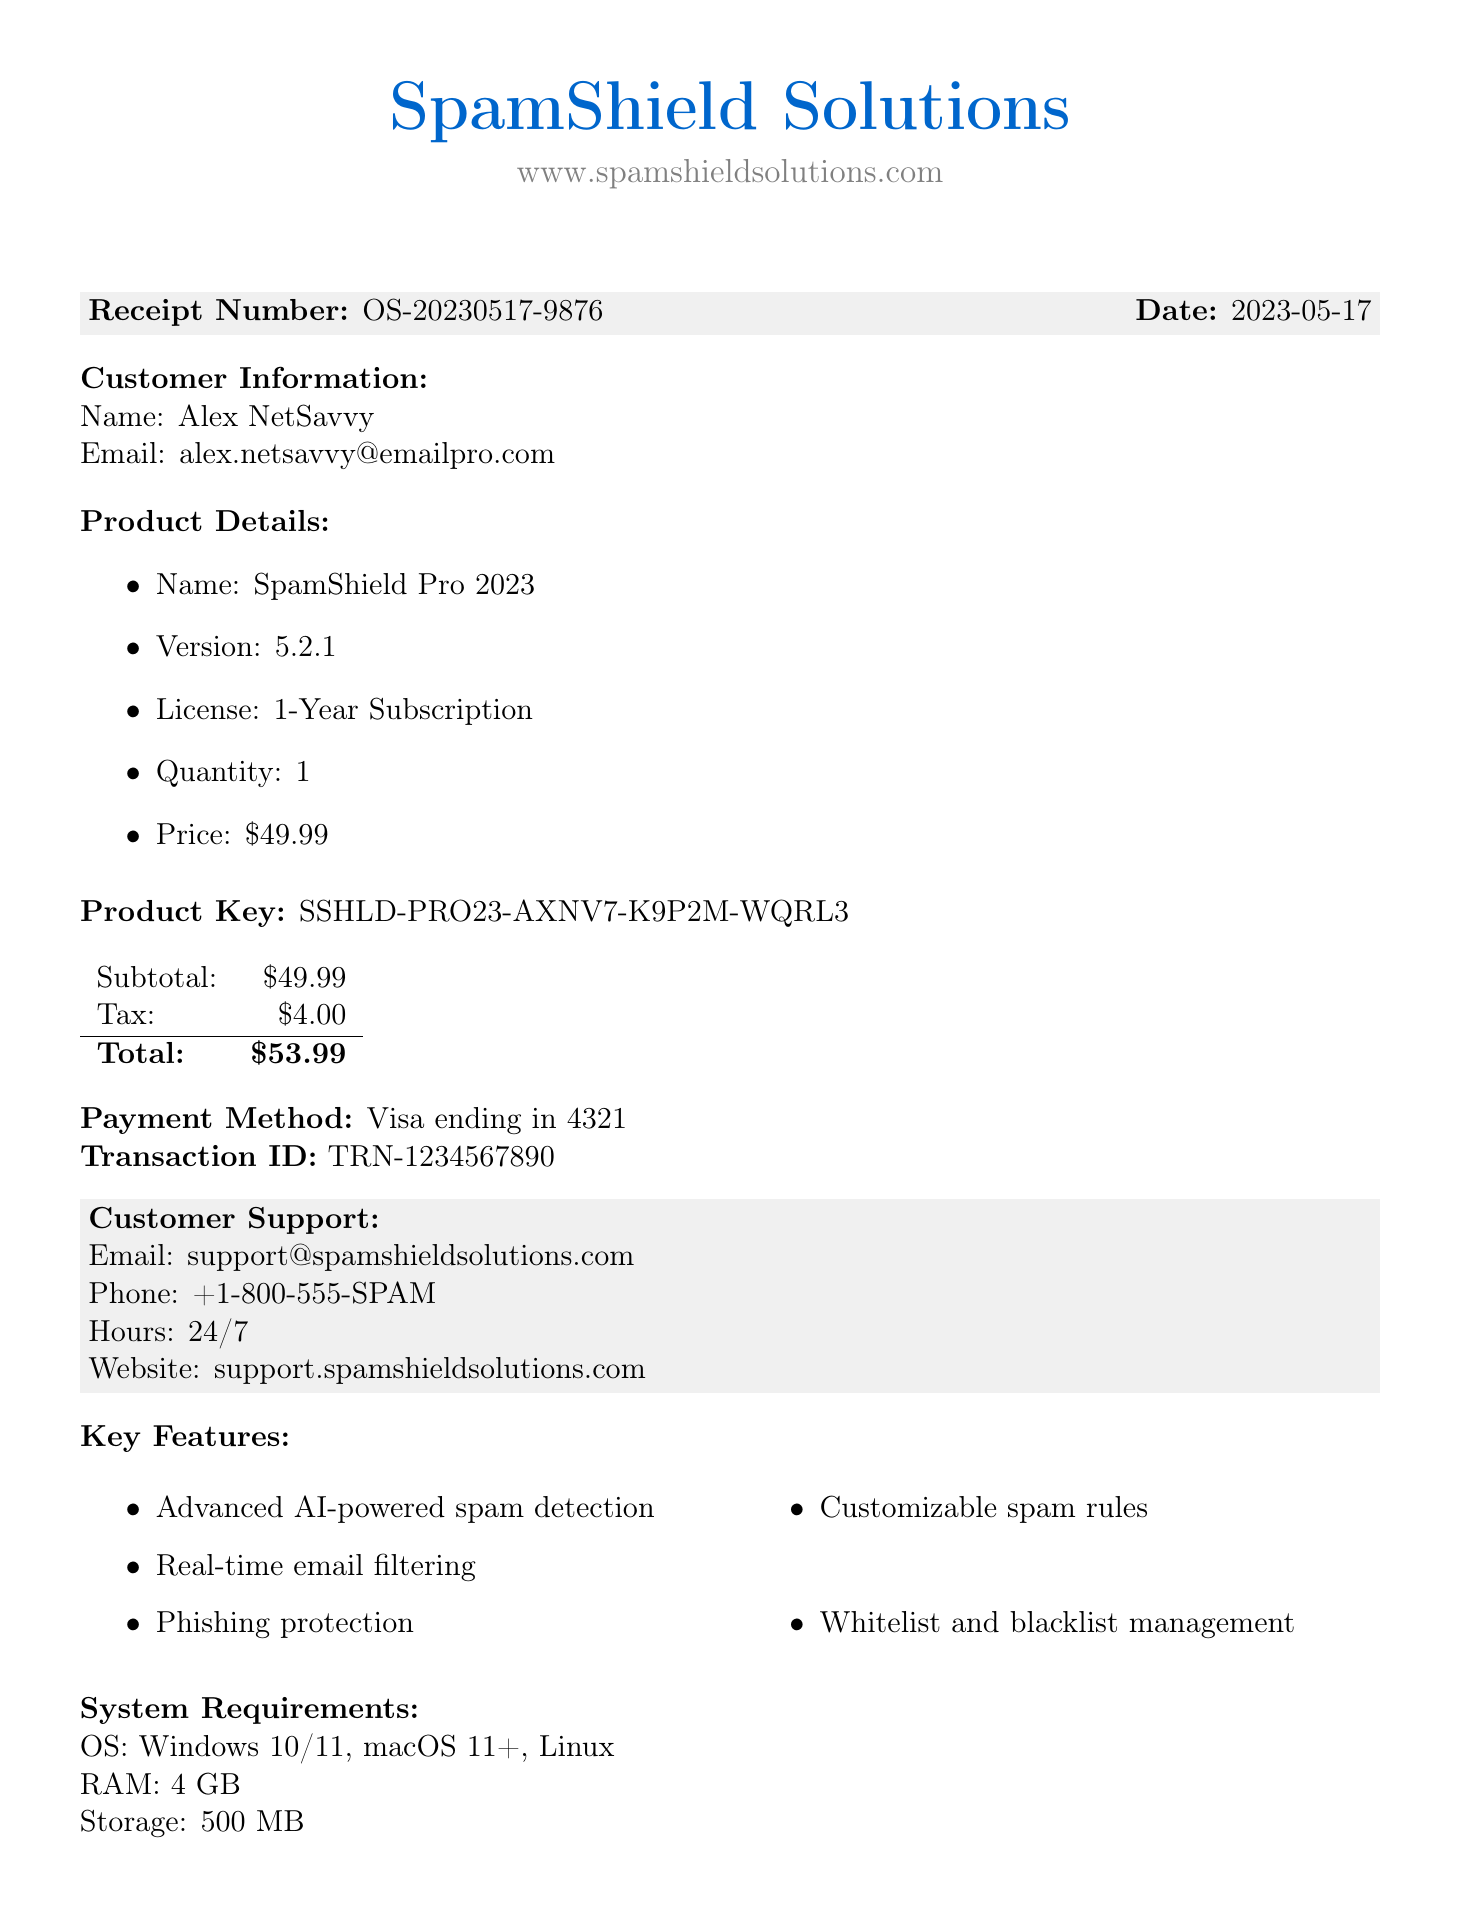What is the receipt number? The receipt number is explicitly stated in the document for identification purposes.
Answer: OS-20230517-9876 Who is the customer? The customer information, including name and email, is provided in the document.
Answer: Alex NetSavvy What is the price of the product? The price is listed in the product details section of the document.
Answer: $49.99 What is the product key? The product key for the software is provided on the receipt.
Answer: SSHLD-PRO23-AXNV7-K9P2M-WQRL3 What is the total amount charged? The total is calculated as the sum of the subtotal and tax listed in the document.
Answer: $53.99 What are the customer support hours? The hours of customer support are mentioned clearly in the support section of the receipt.
Answer: 24/7 How many licenses are included in the purchase? The quantity of the license is specified in the product details section.
Answer: 1 What type of guarantee is offered? The refund policy states the type of guarantee available to the customer.
Answer: 30-day money-back guarantee What is one key feature of the product? The document lists several key features of the software in a separate section.
Answer: Advanced AI-powered spam detection 